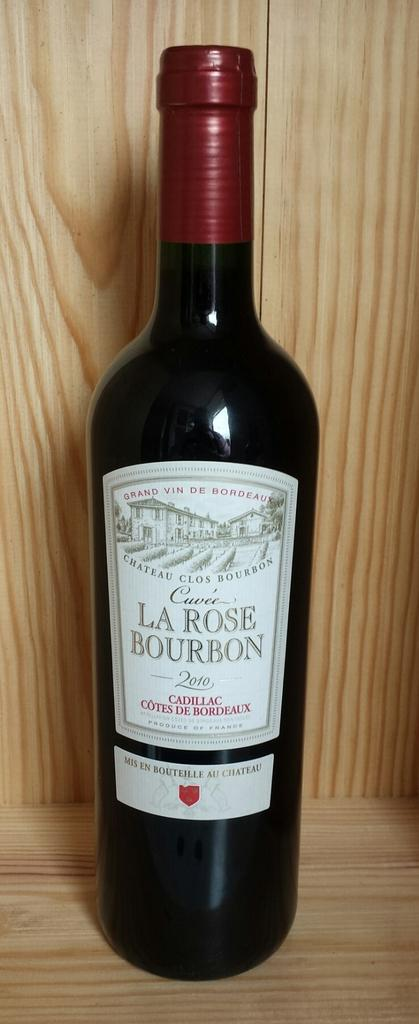<image>
Summarize the visual content of the image. A dark bottle of a La Rose Bourbon wine is on a wooden shelf. 